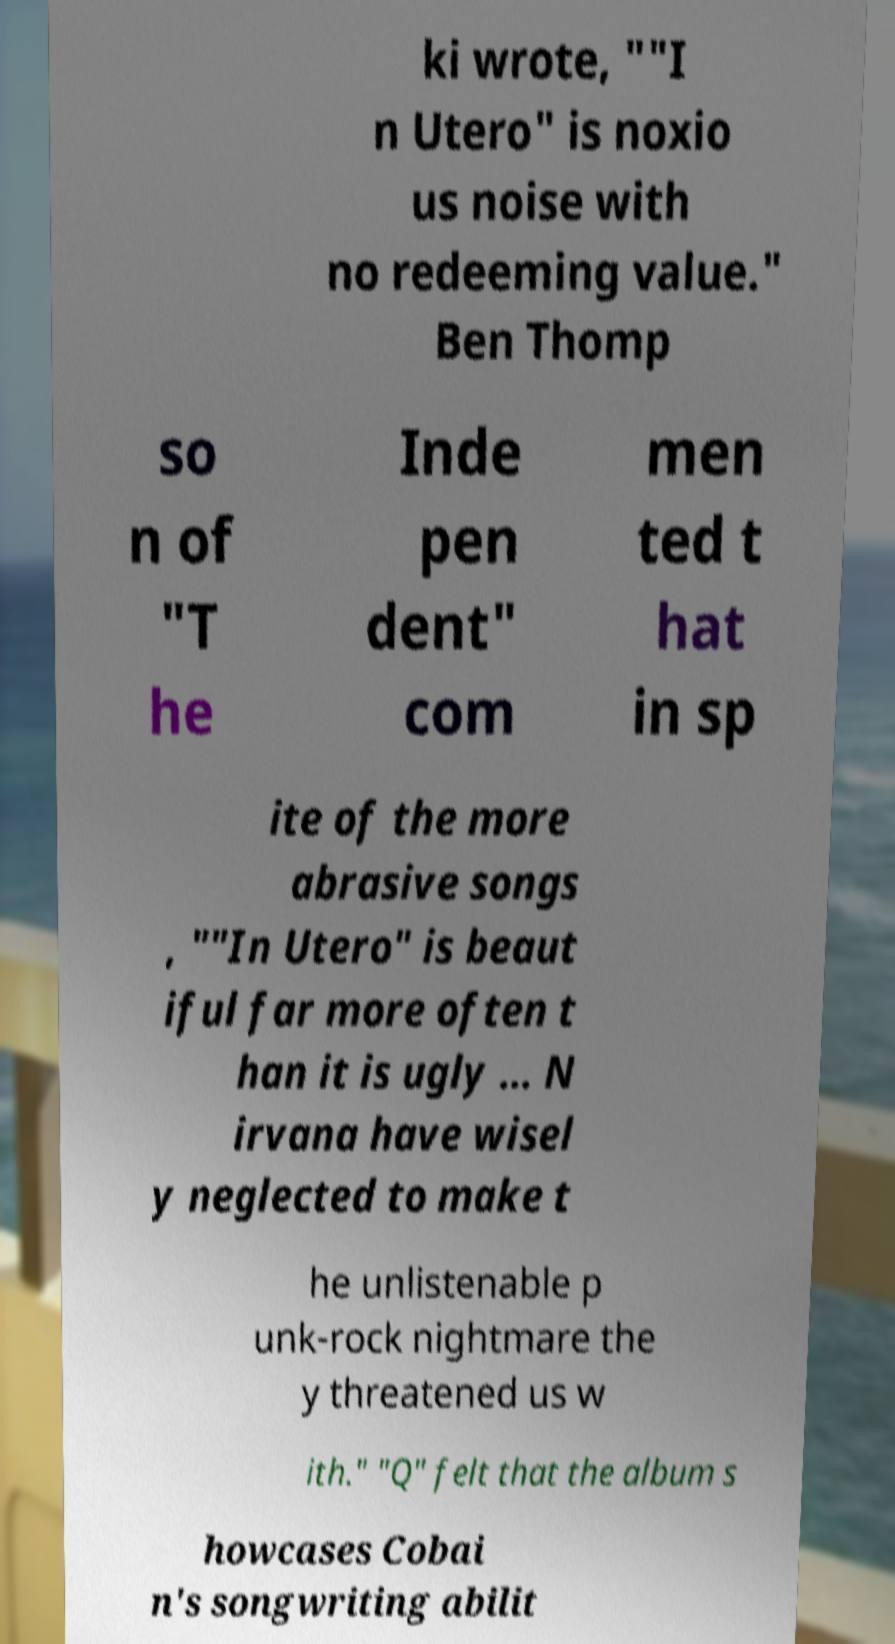For documentation purposes, I need the text within this image transcribed. Could you provide that? ki wrote, ""I n Utero" is noxio us noise with no redeeming value." Ben Thomp so n of "T he Inde pen dent" com men ted t hat in sp ite of the more abrasive songs , ""In Utero" is beaut iful far more often t han it is ugly ... N irvana have wisel y neglected to make t he unlistenable p unk-rock nightmare the y threatened us w ith." "Q" felt that the album s howcases Cobai n's songwriting abilit 